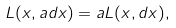Convert formula to latex. <formula><loc_0><loc_0><loc_500><loc_500>L ( x , a d x ) = a L ( x , d x ) ,</formula> 